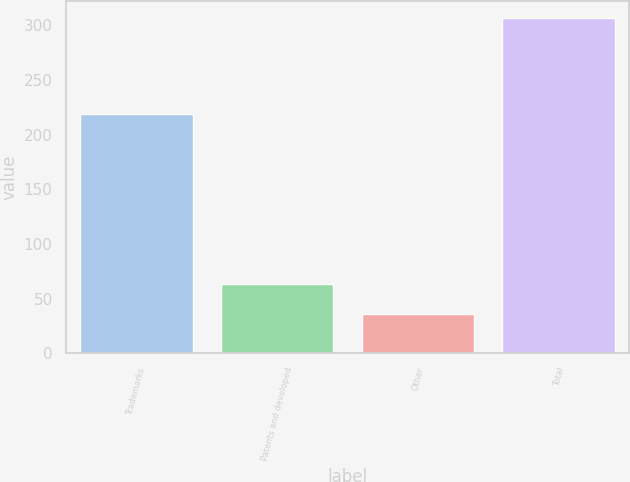<chart> <loc_0><loc_0><loc_500><loc_500><bar_chart><fcel>Trademarks<fcel>Patents and developed<fcel>Other<fcel>Total<nl><fcel>219<fcel>63.1<fcel>36<fcel>307<nl></chart> 